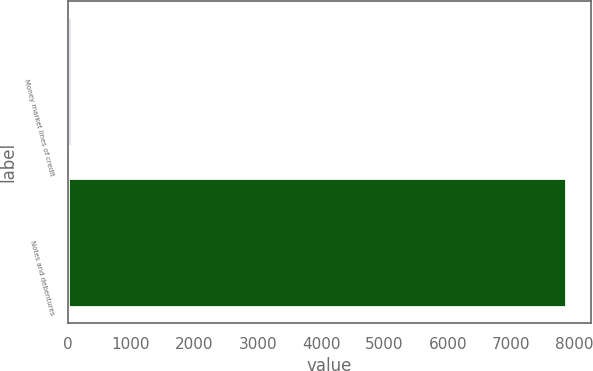Convert chart. <chart><loc_0><loc_0><loc_500><loc_500><bar_chart><fcel>Money market lines of credit<fcel>Notes and debentures<nl><fcel>46<fcel>7870<nl></chart> 